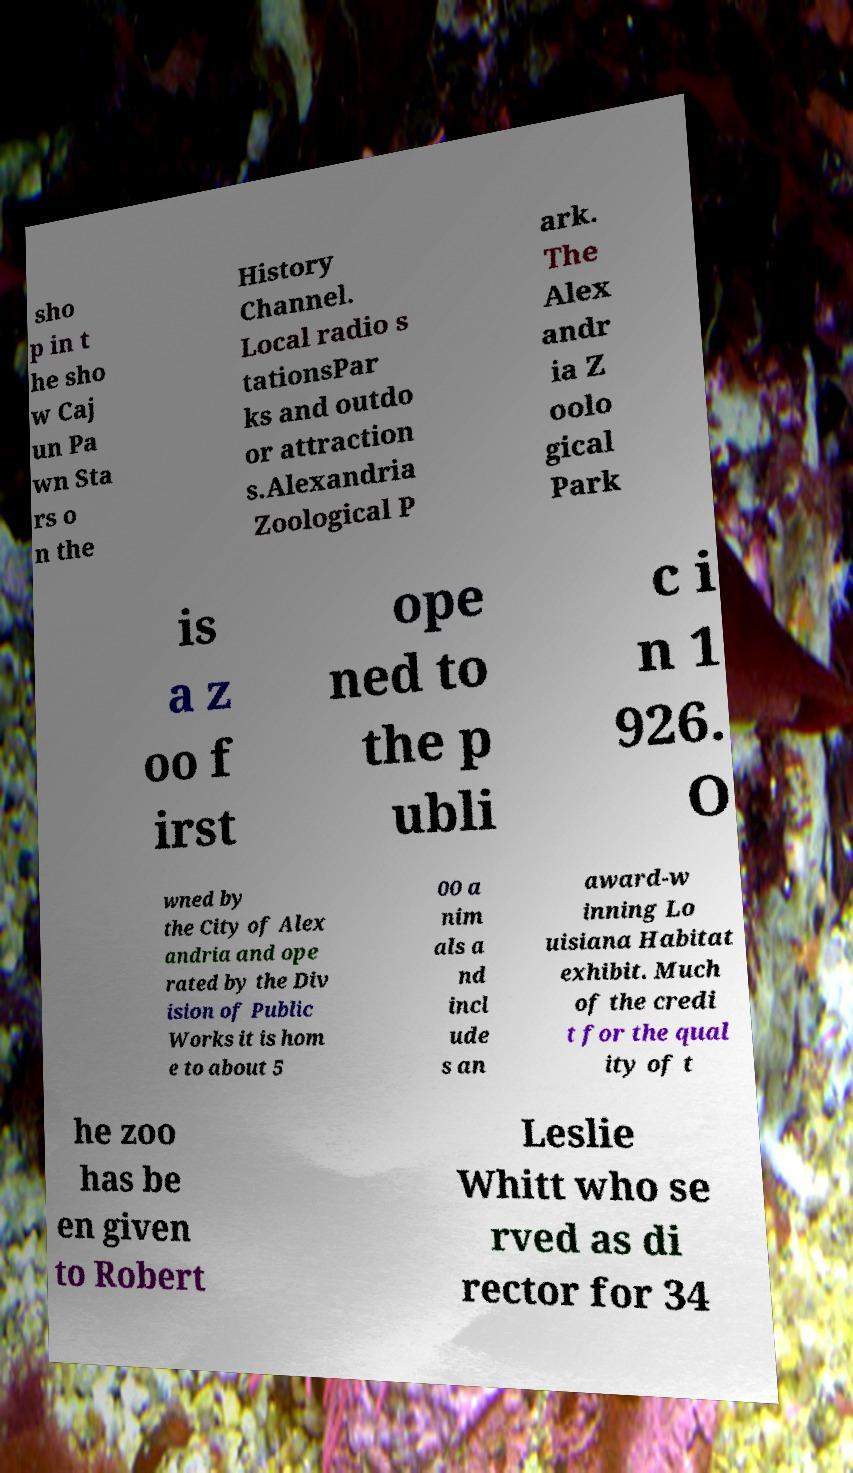What messages or text are displayed in this image? I need them in a readable, typed format. sho p in t he sho w Caj un Pa wn Sta rs o n the History Channel. Local radio s tationsPar ks and outdo or attraction s.Alexandria Zoological P ark. The Alex andr ia Z oolo gical Park is a z oo f irst ope ned to the p ubli c i n 1 926. O wned by the City of Alex andria and ope rated by the Div ision of Public Works it is hom e to about 5 00 a nim als a nd incl ude s an award-w inning Lo uisiana Habitat exhibit. Much of the credi t for the qual ity of t he zoo has be en given to Robert Leslie Whitt who se rved as di rector for 34 